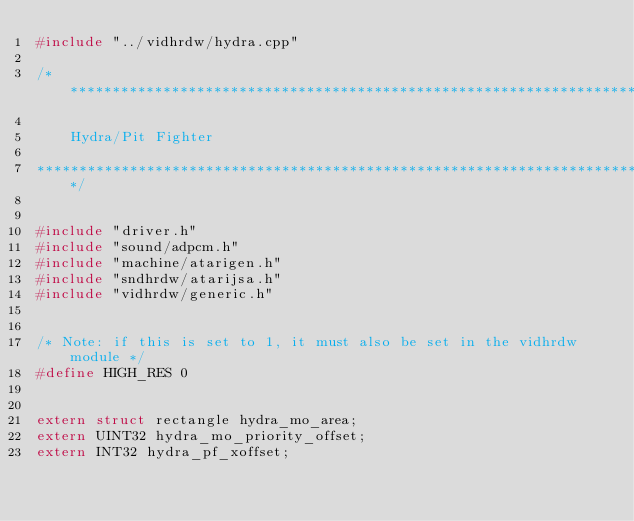Convert code to text. <code><loc_0><loc_0><loc_500><loc_500><_C++_>#include "../vidhrdw/hydra.cpp"

/***************************************************************************

	Hydra/Pit Fighter

****************************************************************************/


#include "driver.h"
#include "sound/adpcm.h"
#include "machine/atarigen.h"
#include "sndhrdw/atarijsa.h"
#include "vidhrdw/generic.h"


/* Note: if this is set to 1, it must also be set in the vidhrdw module */
#define HIGH_RES 0


extern struct rectangle hydra_mo_area;
extern UINT32 hydra_mo_priority_offset;
extern INT32 hydra_pf_xoffset;

</code> 